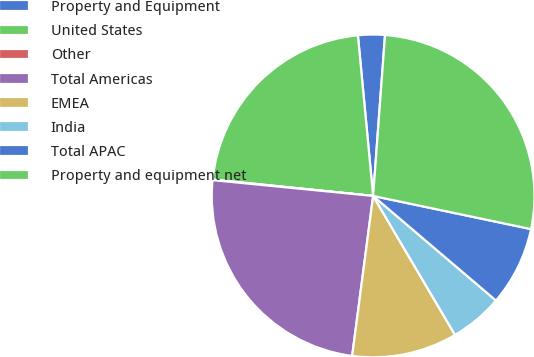Convert chart to OTSL. <chart><loc_0><loc_0><loc_500><loc_500><pie_chart><fcel>Property and Equipment<fcel>United States<fcel>Other<fcel>Total Americas<fcel>EMEA<fcel>India<fcel>Total APAC<fcel>Property and equipment net<nl><fcel>2.68%<fcel>21.87%<fcel>0.06%<fcel>24.49%<fcel>10.55%<fcel>5.3%<fcel>7.93%<fcel>27.12%<nl></chart> 